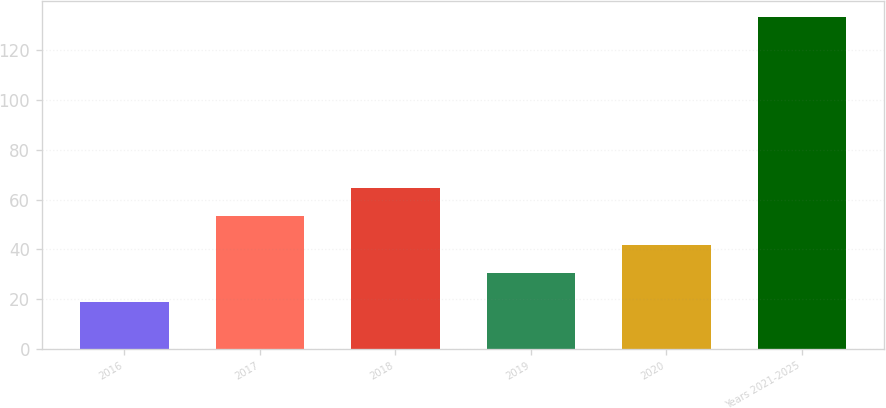Convert chart. <chart><loc_0><loc_0><loc_500><loc_500><bar_chart><fcel>2016<fcel>2017<fcel>2018<fcel>2019<fcel>2020<fcel>Years 2021-2025<nl><fcel>18.9<fcel>53.22<fcel>64.66<fcel>30.34<fcel>41.78<fcel>133.3<nl></chart> 